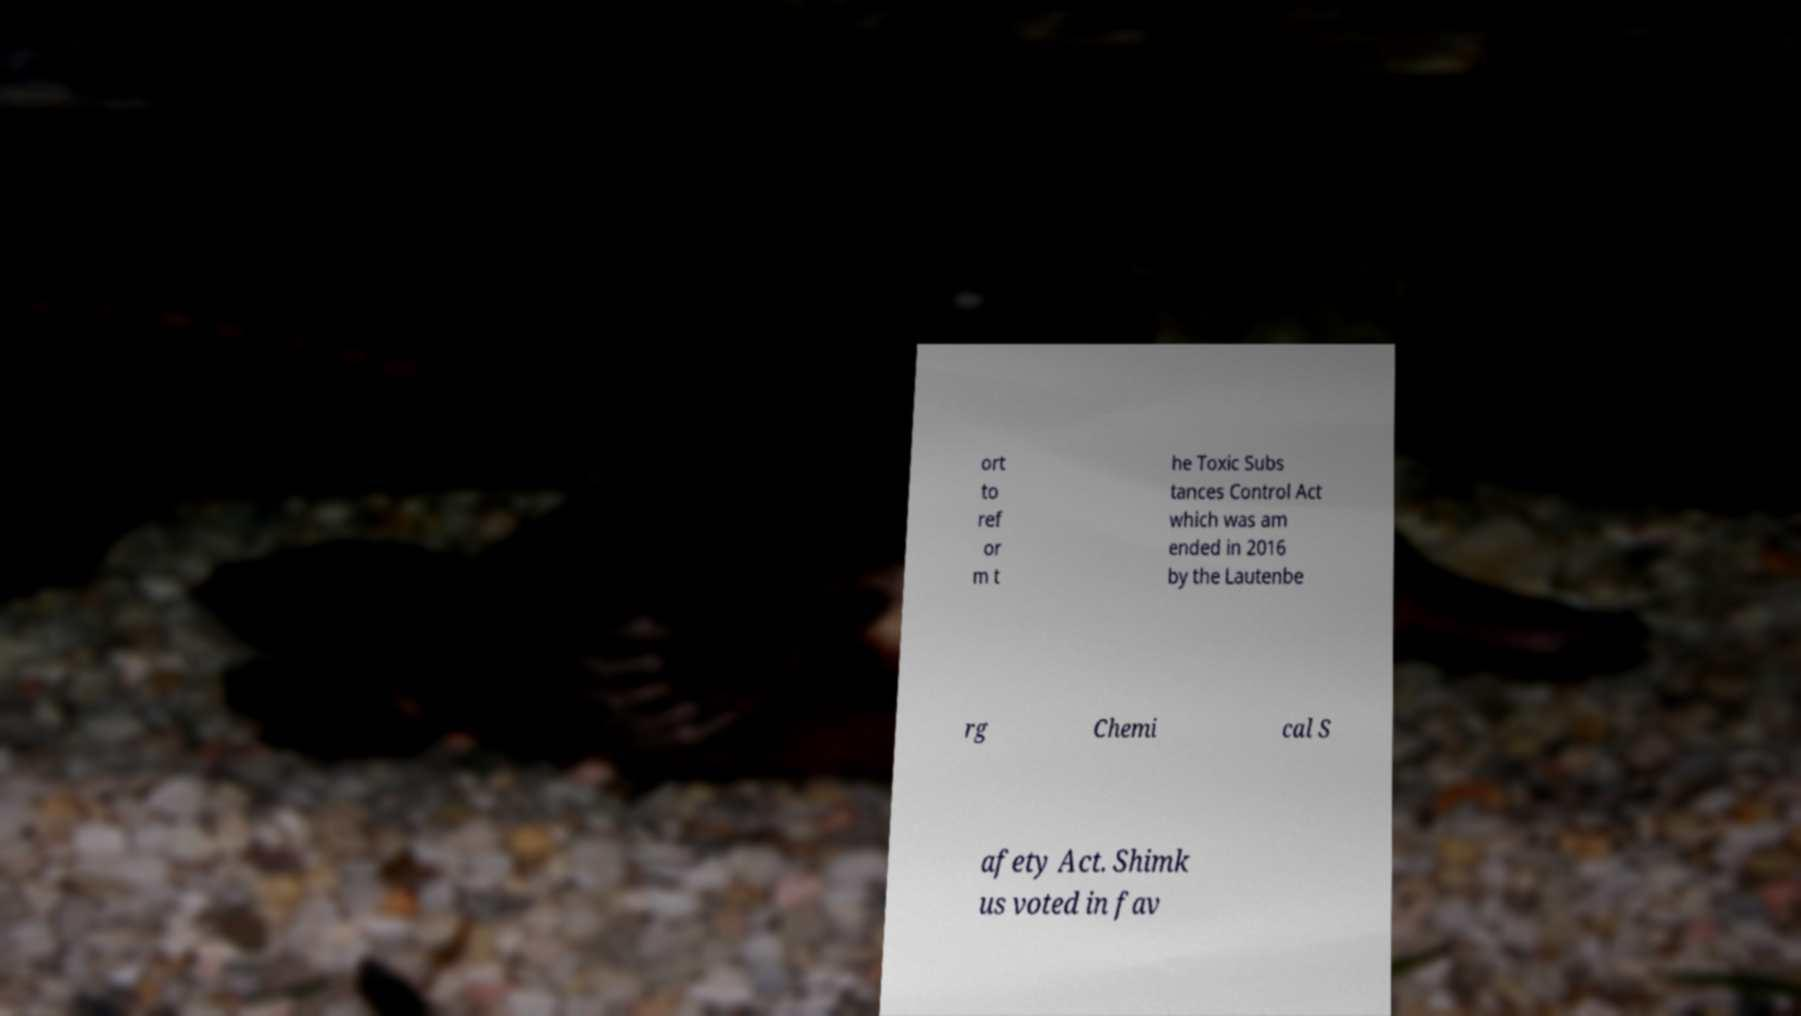Could you extract and type out the text from this image? ort to ref or m t he Toxic Subs tances Control Act which was am ended in 2016 by the Lautenbe rg Chemi cal S afety Act. Shimk us voted in fav 